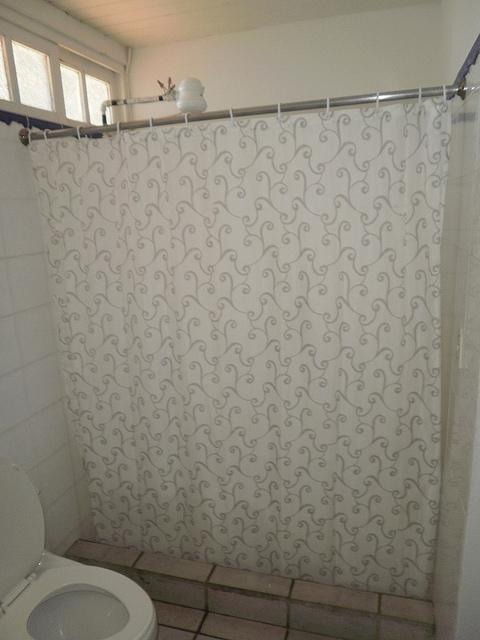Where is the shower curtain?
Quick response, please. Rod. Is the toilet seat up?
Concise answer only. No. What type of basin is behind the curtain?
Answer briefly. Shower. What is this room's use?
Answer briefly. Bathroom. 